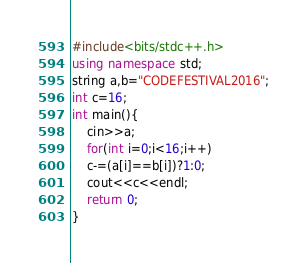Convert code to text. <code><loc_0><loc_0><loc_500><loc_500><_C++_>#include<bits/stdc++.h>
using namespace std;
string a,b="CODEFESTIVAL2016";
int c=16;
int main(){
    cin>>a;
    for(int i=0;i<16;i++)
    c-=(a[i]==b[i])?1:0;
    cout<<c<<endl;
    return 0;
}</code> 